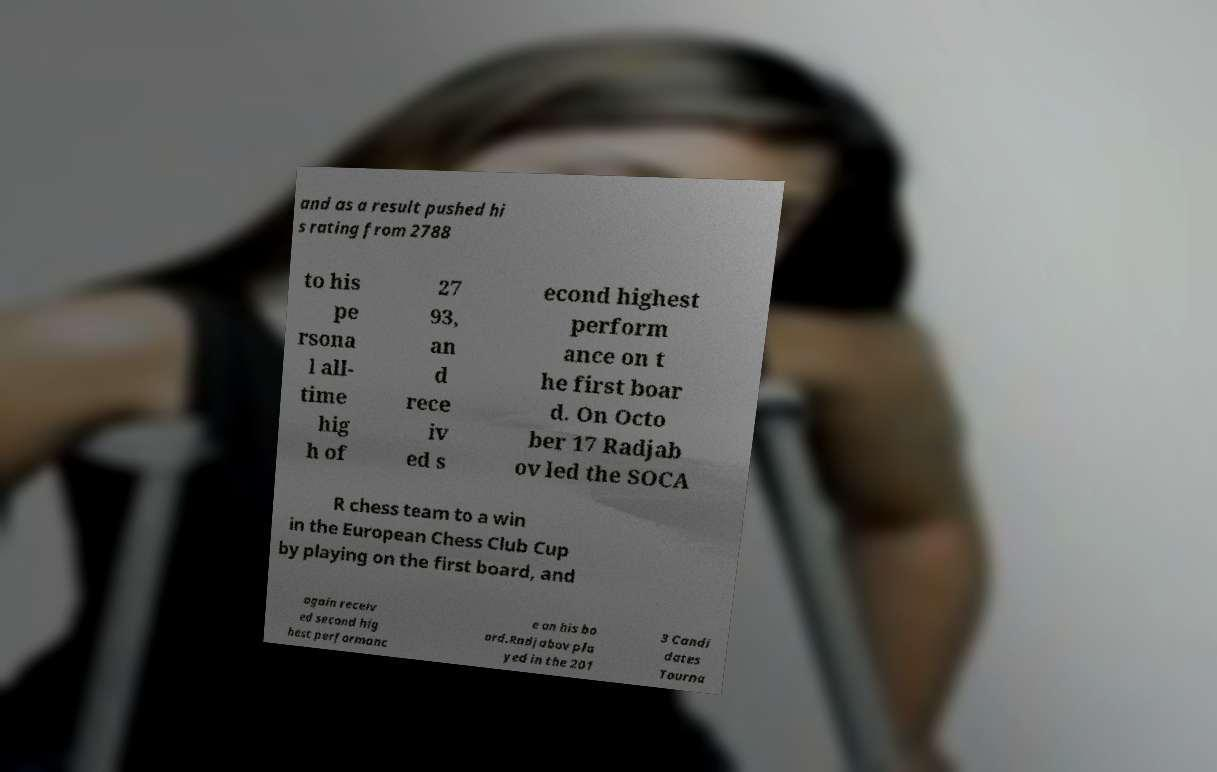Can you read and provide the text displayed in the image?This photo seems to have some interesting text. Can you extract and type it out for me? and as a result pushed hi s rating from 2788 to his pe rsona l all- time hig h of 27 93, an d rece iv ed s econd highest perform ance on t he first boar d. On Octo ber 17 Radjab ov led the SOCA R chess team to a win in the European Chess Club Cup by playing on the first board, and again receiv ed second hig hest performanc e on his bo ard.Radjabov pla yed in the 201 3 Candi dates Tourna 